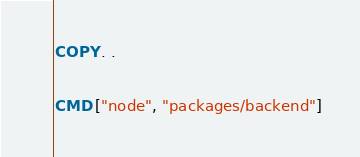Convert code to text. <code><loc_0><loc_0><loc_500><loc_500><_Dockerfile_>COPY . .

CMD ["node", "packages/backend"]
</code> 